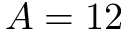Convert formula to latex. <formula><loc_0><loc_0><loc_500><loc_500>A = 1 2</formula> 